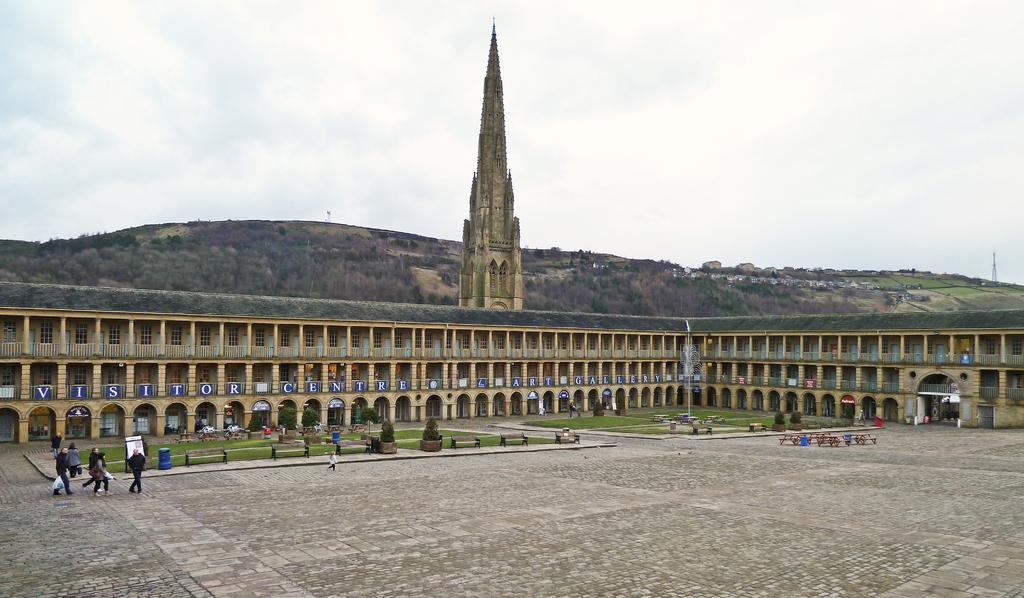How would you summarize this image in a sentence or two? In this image we can see a building, tower, name boards, persons and other objects. In the background of the image there are mountains, poles and other objects. At the top of the image there is the sky. At the bottom of the image there is the floor. 